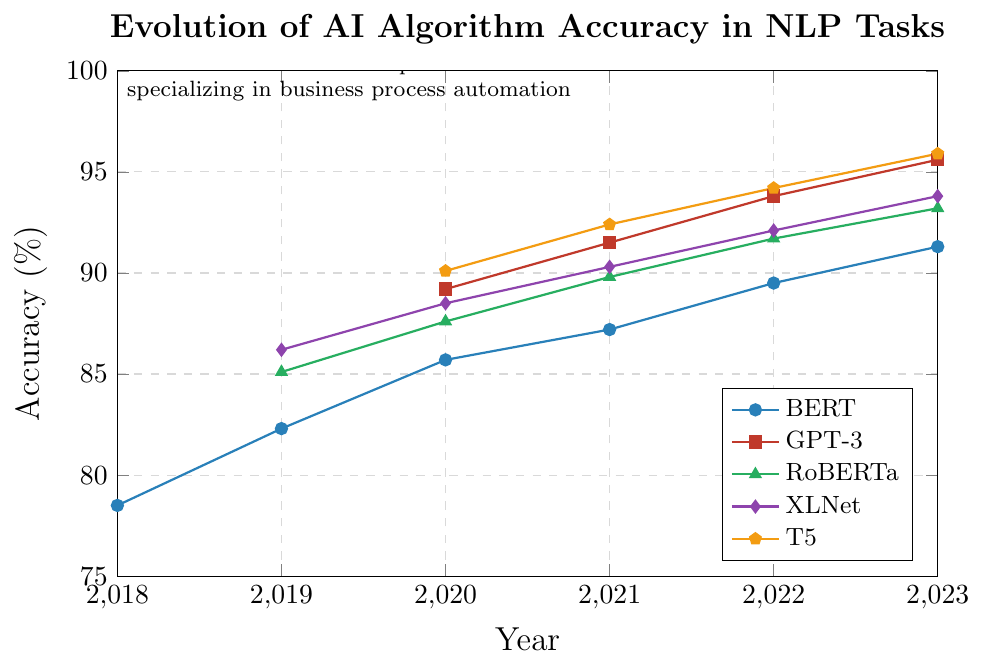What year did GPT-3 first appear in the chart? Identify the first year GPT-3 has an accuracy value. It appears in 2020.
Answer: 2020 Which model shows the greatest increase in accuracy between its first and last recorded year? Calculate the difference between the first and last recorded accuracies for each model: BERT (91.3 - 78.5 = 12.8), GPT-3 (95.6 - 89.2 = 6.4), RoBERTa (93.2 - 85.1 = 8.1), XLNet (93.8 - 86.2 = 7.6), T5 (95.9 - 90.1 = 5.8). The greatest increase is for BERT with 12.8%.
Answer: BERT What is the accuracy difference between RoBERTa and XLNet in 2023? Look at the 2023 values for RoBERTa (93.2) and XLNet (93.8) and calculate the difference: 93.8 - 93.2 = 0.6%.
Answer: 0.6% Which model had the highest accuracy in 2021? Compare the accuracies of all models in 2021: BERT (87.2), GPT-3 (91.5), RoBERTa (89.8), XLNet (90.3), T5 (92.4). T5 has the highest accuracy in 2021 with 92.4%.
Answer: T5 How many years does the chart cover for BERT? Count the number of years from the first to the last data point for BERT, which is 6 years (2018 to 2023).
Answer: 6 Which model had no recorded accuracy until 2020? Models with no data until 2020 are GPT-3 and T5, as their first recorded accuracies are in 2020.
Answer: GPT-3 and T5 What is the combined accuracy of BERT and RoBERTa in 2020? Add the accuracy values of BERT (85.7) and RoBERTa (87.6) in 2020, getting 85.7 + 87.6 = 173.3%.
Answer: 173.3% Which model achieved over 90% accuracy first? Review the data to see the first instance each model reaches or exceeds 90% accuracy: T5 in 2020 with 90.1%.
Answer: T5 In which year did both XLNet and RoBERTa have their lowest recorded accuracies? Find the years with the lowest accuracies for XLNet (86.2 in 2019) and RoBERTa (85.1 in 2019). Both have their lowest accuracies in 2019.
Answer: 2019 